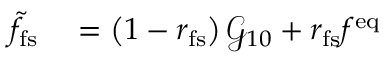<formula> <loc_0><loc_0><loc_500><loc_500>\begin{array} { r l } { \tilde { f } _ { f s } } & = \left ( 1 - r _ { f s } \right ) \mathcal { G } _ { 1 0 } + r _ { f s } f ^ { e q } } \end{array}</formula> 